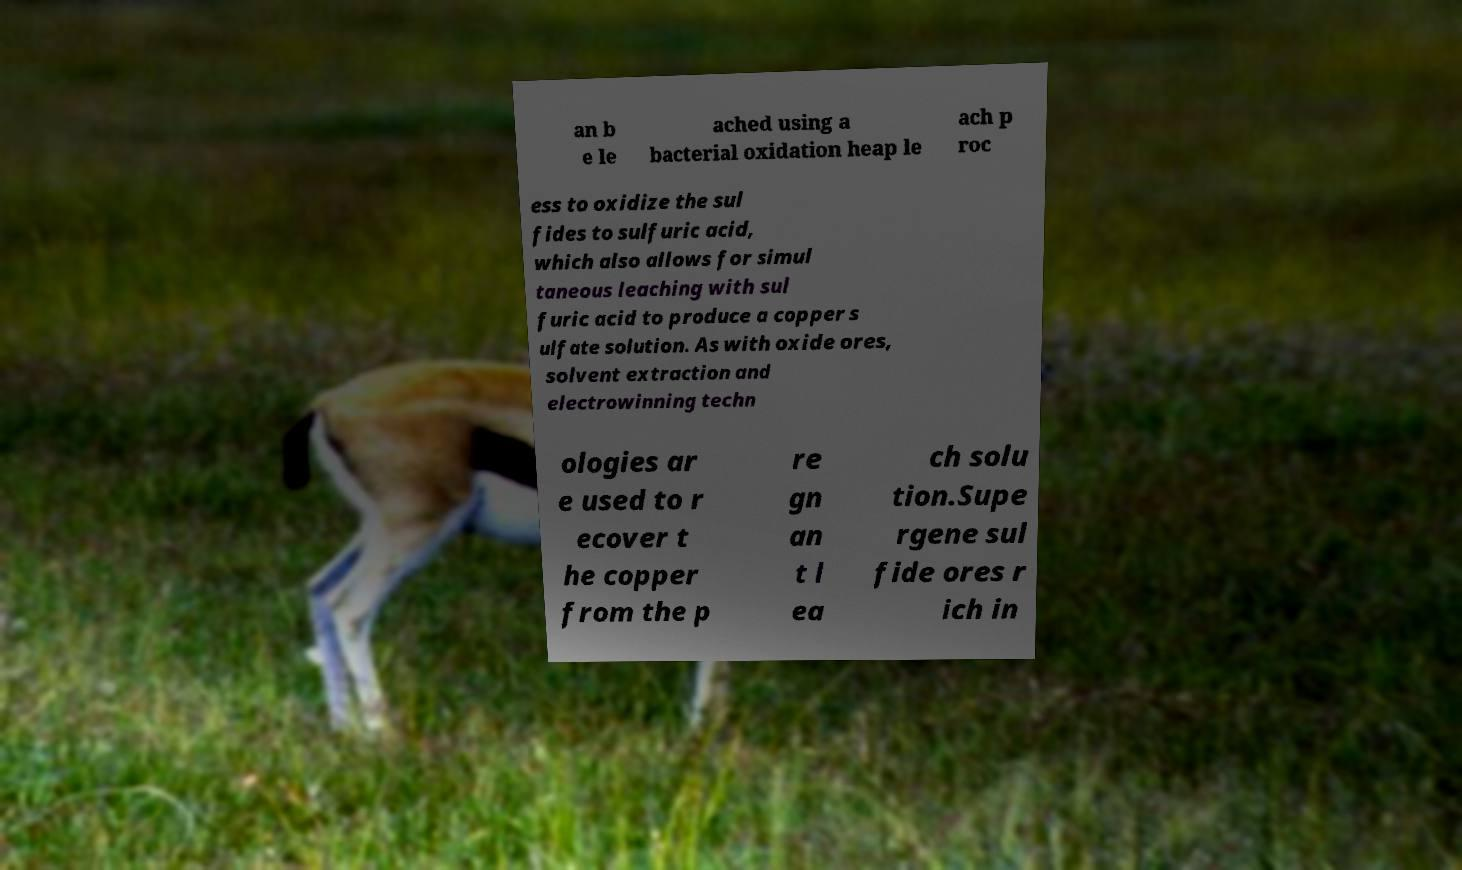What messages or text are displayed in this image? I need them in a readable, typed format. an b e le ached using a bacterial oxidation heap le ach p roc ess to oxidize the sul fides to sulfuric acid, which also allows for simul taneous leaching with sul furic acid to produce a copper s ulfate solution. As with oxide ores, solvent extraction and electrowinning techn ologies ar e used to r ecover t he copper from the p re gn an t l ea ch solu tion.Supe rgene sul fide ores r ich in 